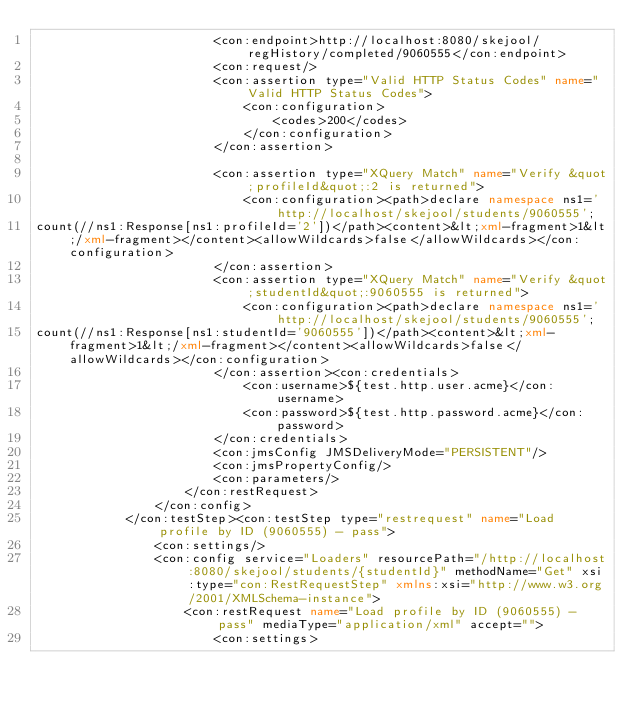<code> <loc_0><loc_0><loc_500><loc_500><_XML_>                        <con:endpoint>http://localhost:8080/skejool/regHistory/completed/9060555</con:endpoint>
                        <con:request/>
                        <con:assertion type="Valid HTTP Status Codes" name="Valid HTTP Status Codes">
                            <con:configuration>
                                <codes>200</codes>
                            </con:configuration>
                        </con:assertion>
                        
                        <con:assertion type="XQuery Match" name="Verify &quot;profileId&quot;:2 is returned">
                            <con:configuration><path>declare namespace ns1='http://localhost/skejool/students/9060555';
count(//ns1:Response[ns1:profileId='2'])</path><content>&lt;xml-fragment>1&lt;/xml-fragment></content><allowWildcards>false</allowWildcards></con:configuration>
                        </con:assertion>
                        <con:assertion type="XQuery Match" name="Verify &quot;studentId&quot;:9060555 is returned">
                            <con:configuration><path>declare namespace ns1='http://localhost/skejool/students/9060555';
count(//ns1:Response[ns1:studentId='9060555'])</path><content>&lt;xml-fragment>1&lt;/xml-fragment></content><allowWildcards>false</allowWildcards></con:configuration>
                        </con:assertion><con:credentials>
                            <con:username>${test.http.user.acme}</con:username>
                            <con:password>${test.http.password.acme}</con:password>
                        </con:credentials>
                        <con:jmsConfig JMSDeliveryMode="PERSISTENT"/>
                        <con:jmsPropertyConfig/>
                        <con:parameters/>
                    </con:restRequest>
                </con:config>
            </con:testStep><con:testStep type="restrequest" name="Load profile by ID (9060555) - pass">
                <con:settings/>
                <con:config service="Loaders" resourcePath="/http://localhost:8080/skejool/students/{studentId}" methodName="Get" xsi:type="con:RestRequestStep" xmlns:xsi="http://www.w3.org/2001/XMLSchema-instance">
                    <con:restRequest name="Load profile by ID (9060555) - pass" mediaType="application/xml" accept="">
                        <con:settings></code> 